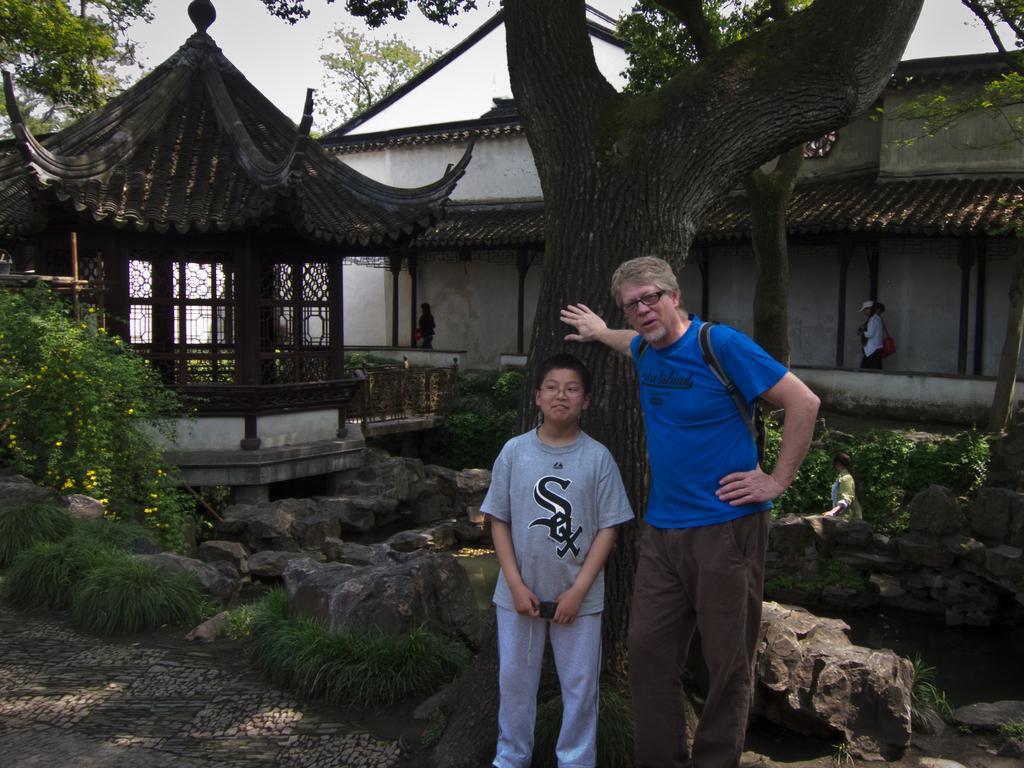How would you summarize this image in a sentence or two? In this picture, there is a kid and a man standing before the tree. Man is wearing a blue t shirt, brown trousers and carrying a hat. Towards the left, there is a wooden stones. In the center, there are stones and plants. In the background, there is a building with roof tiles. On the top, there are trees and sky. 